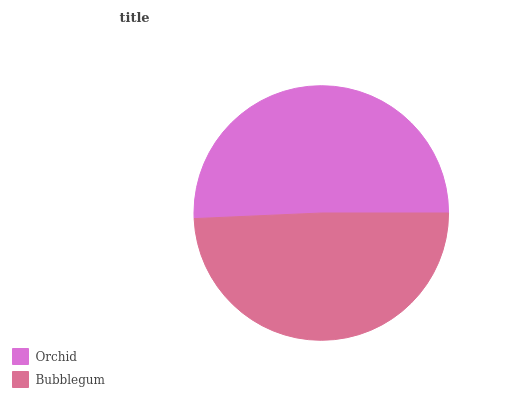Is Bubblegum the minimum?
Answer yes or no. Yes. Is Orchid the maximum?
Answer yes or no. Yes. Is Bubblegum the maximum?
Answer yes or no. No. Is Orchid greater than Bubblegum?
Answer yes or no. Yes. Is Bubblegum less than Orchid?
Answer yes or no. Yes. Is Bubblegum greater than Orchid?
Answer yes or no. No. Is Orchid less than Bubblegum?
Answer yes or no. No. Is Orchid the high median?
Answer yes or no. Yes. Is Bubblegum the low median?
Answer yes or no. Yes. Is Bubblegum the high median?
Answer yes or no. No. Is Orchid the low median?
Answer yes or no. No. 